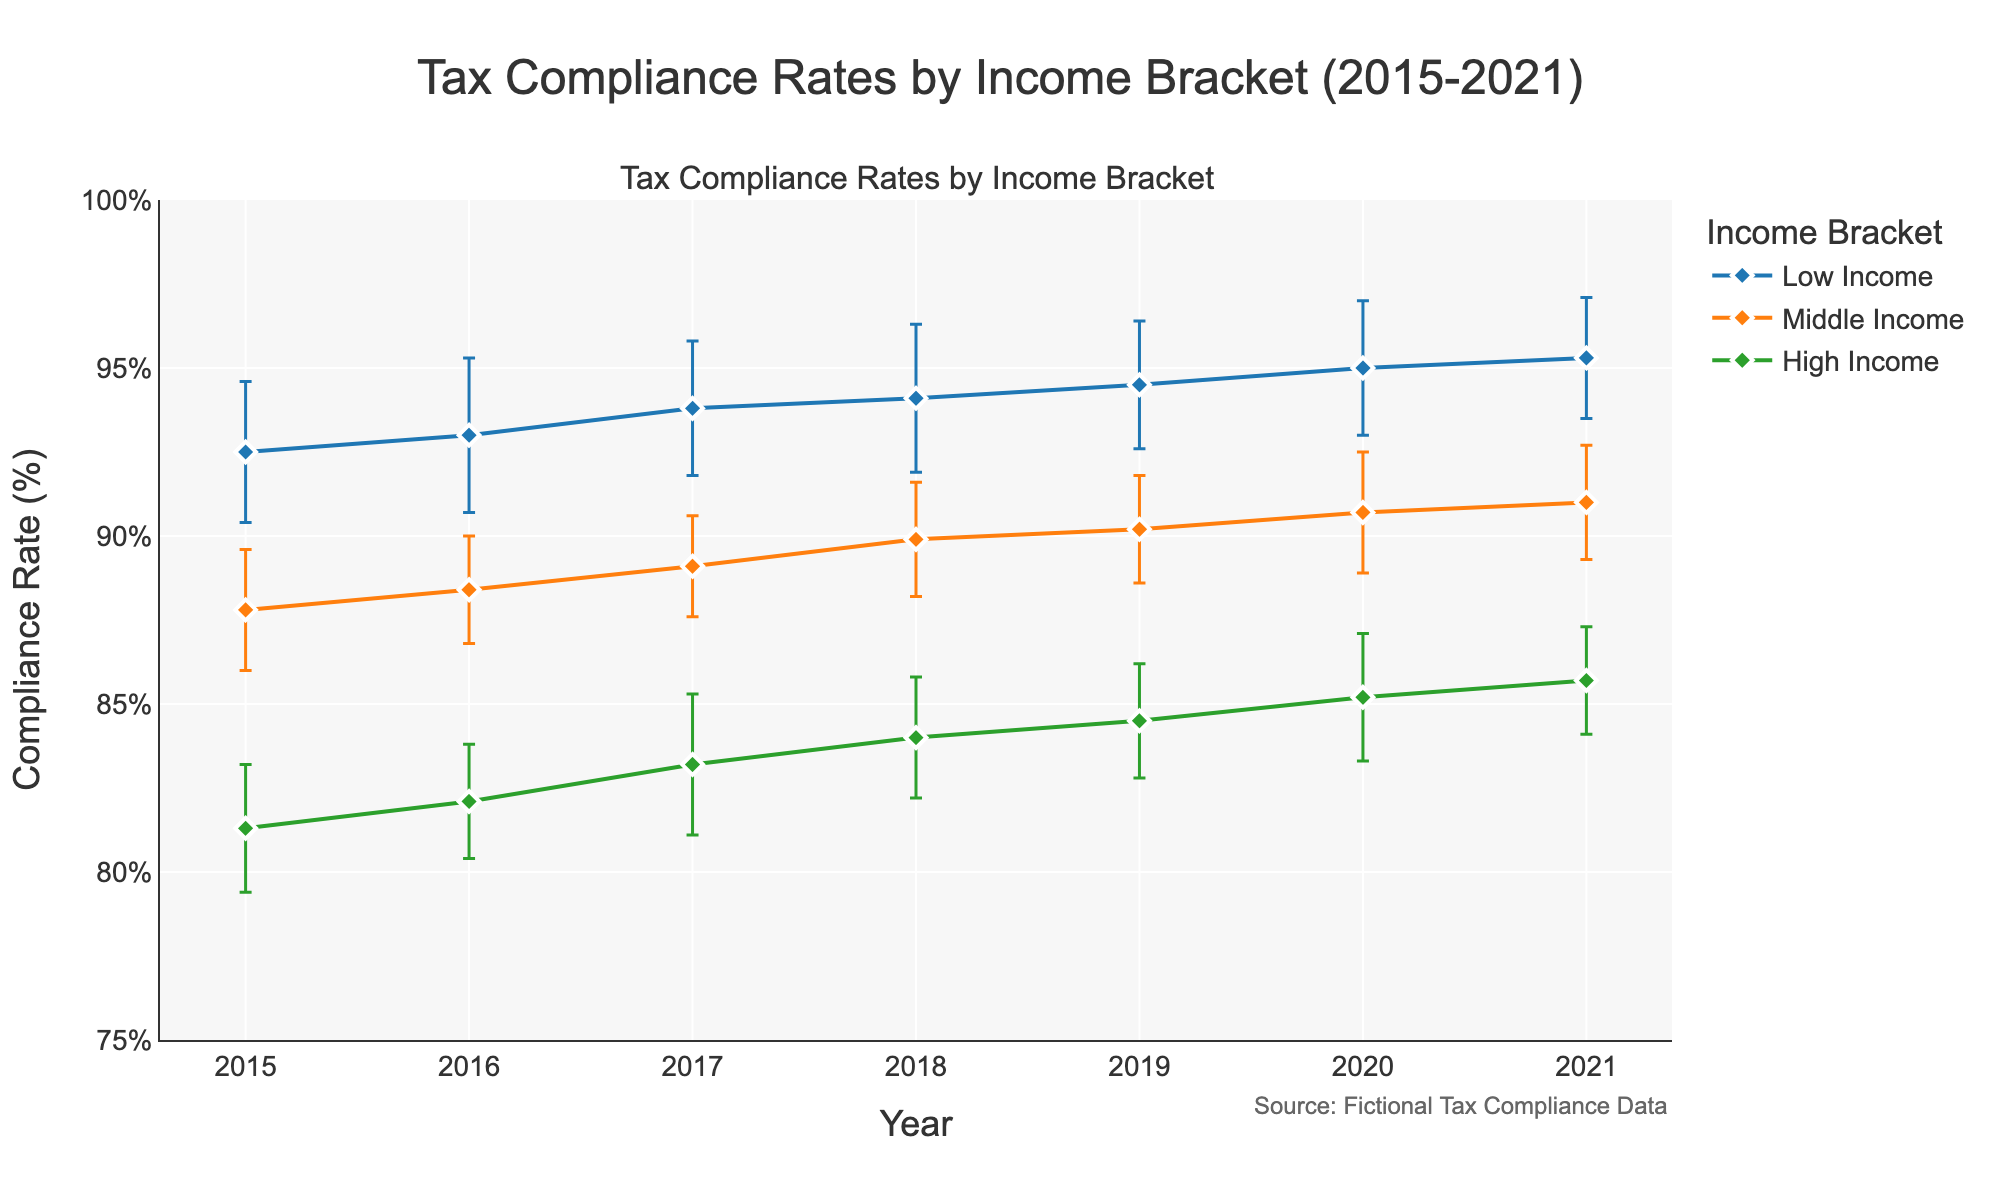What is the title of the figure? The title is located at the top of the figure. The figure title is "Tax Compliance Rates by Income Bracket (2015-2021)"
Answer: Tax Compliance Rates by Income Bracket (2015-2021) Which tax bracket has the highest compliance rate in 2021? By looking at the year 2021 on the x-axis and comparing the compliance rates of each tax bracket, the Low Income bracket has the highest rate around 95.3%
Answer: Low Income What is the range of the y-axis? The y-axis range is indicated by tick marks and values, ranging from 75% to 100% as specified in the figure label and axis
Answer: 75% to 100% What trend can you observe for the Low Income compliance rate over the years? Observing the Low Income line from 2015 to 2021, it shows a rising trend indicating an increase from around 92.5% to approximately 95.3%
Answer: Rising trend What is the error margin for the High Income tax bracket in 2019? The error bar (vertical line) on the High Income data point in 2019 gives the error margin, which is 1.7%
Answer: 1.7% How does the Middle Income compliance rate in 2018 compare with the Low Income compliance rate in 2016? The Middle Income compliance rate in 2018 is around 89.9%, while the Low Income compliance rate in 2016 is around 93.0%. The Low Income rate in 2016 is higher
Answer: Low Income rate in 2016 is higher What is the average compliance rate for the High Income bracket over the seven years shown? To find the average, sum the compliance rates for the High Income bracket from 2015 to 2021 (81.3 + 82.1 + 83.2 + 84.0 + 84.5 + 85.2 + 85.7) and then divide by 7. This results in (81.3 + 82.1 + 83.2 + 84.0 + 84.5 + 85.2 + 85.7) / 7 = 85.71%
Answer: 84.0% Which year shows the smallest error margin for the Middle Income bracket? By inspecting the error bars for the Middle Income bracket across all years, the smallest error margin is in 2017, where it is 1.5%.
Answer: 2017 Compare the trend in compliance rates for Low Income and High Income brackets over the years. The Low Income bracket shows a continuous rising trend from 92.5% in 2015 to 95.3% in 2021, while the High Income bracket also shows an increase but at a lower rate from 81.3% in 2015 to 85.7% in 2021. Both trends are upward but the Low Income trend is steeper.
Answer: Both are rising, Low Income's rise is steeper What can be inferred about the error variability across different tax brackets? By comparing the lengths of the error bars of different tax brackets, we can see there is variability but generally, the Low Income bracket has relatively larger error margins while the Middle Income bracket tends to have smaller margins
Answer: Larger for Low Income, smaller for Middle Income 